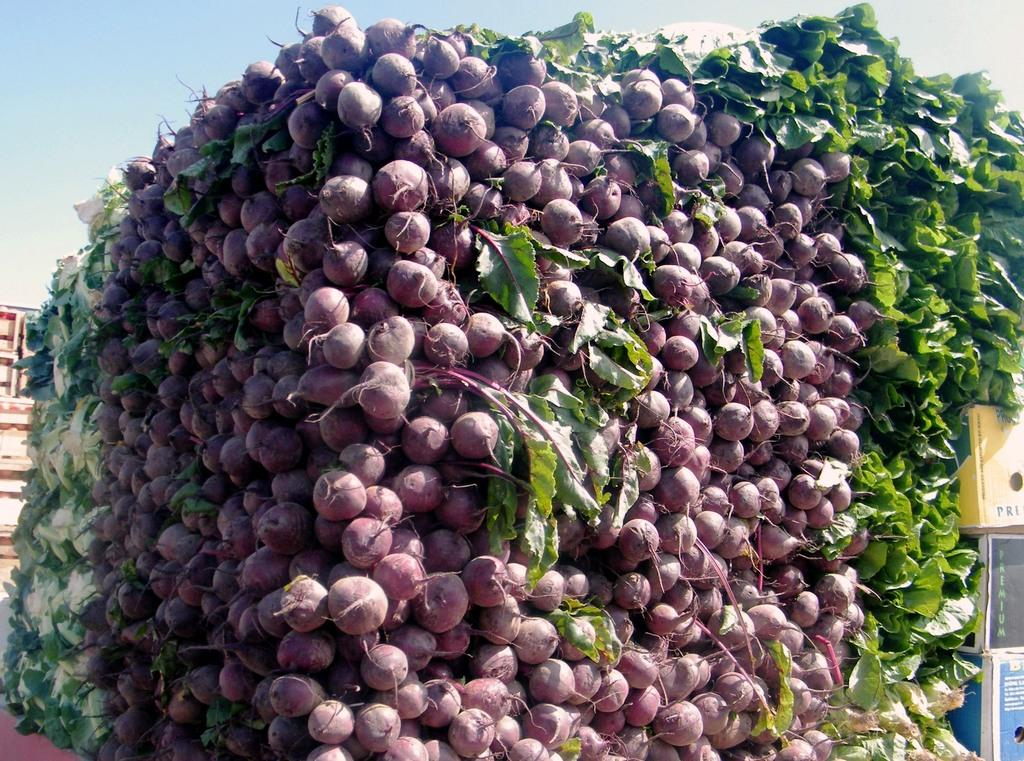What type of vegetables are in the image? There is a bunch of turnips and leafy vegetables in the image. Are there any other types of vegetables present? Yes, there are cabbages in the image. How are the vegetables arranged? The vegetables are arranged in a block. What can be seen on the right side of the image? There are cardboard boxes on the right side of the image. What is visible above the cardboard boxes? The sky is visible above the cardboard boxes. What type of band is playing music in the image? There is no band present in the image; it features vegetables arranged in a block and cardboard boxes. 